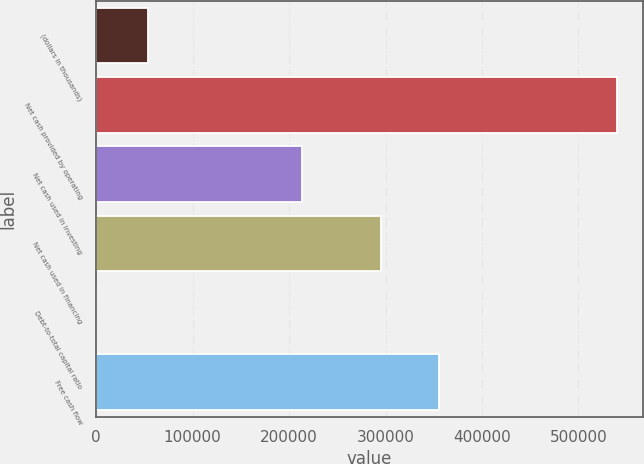Convert chart. <chart><loc_0><loc_0><loc_500><loc_500><bar_chart><fcel>(dollars in thousands)<fcel>Net cash provided by operating<fcel>Net cash used in investing<fcel>Net cash used in financing<fcel>Debt-to-total capital ratio<fcel>Free cash flow<nl><fcel>53974.9<fcel>539505<fcel>213224<fcel>294792<fcel>27.1<fcel>355357<nl></chart> 